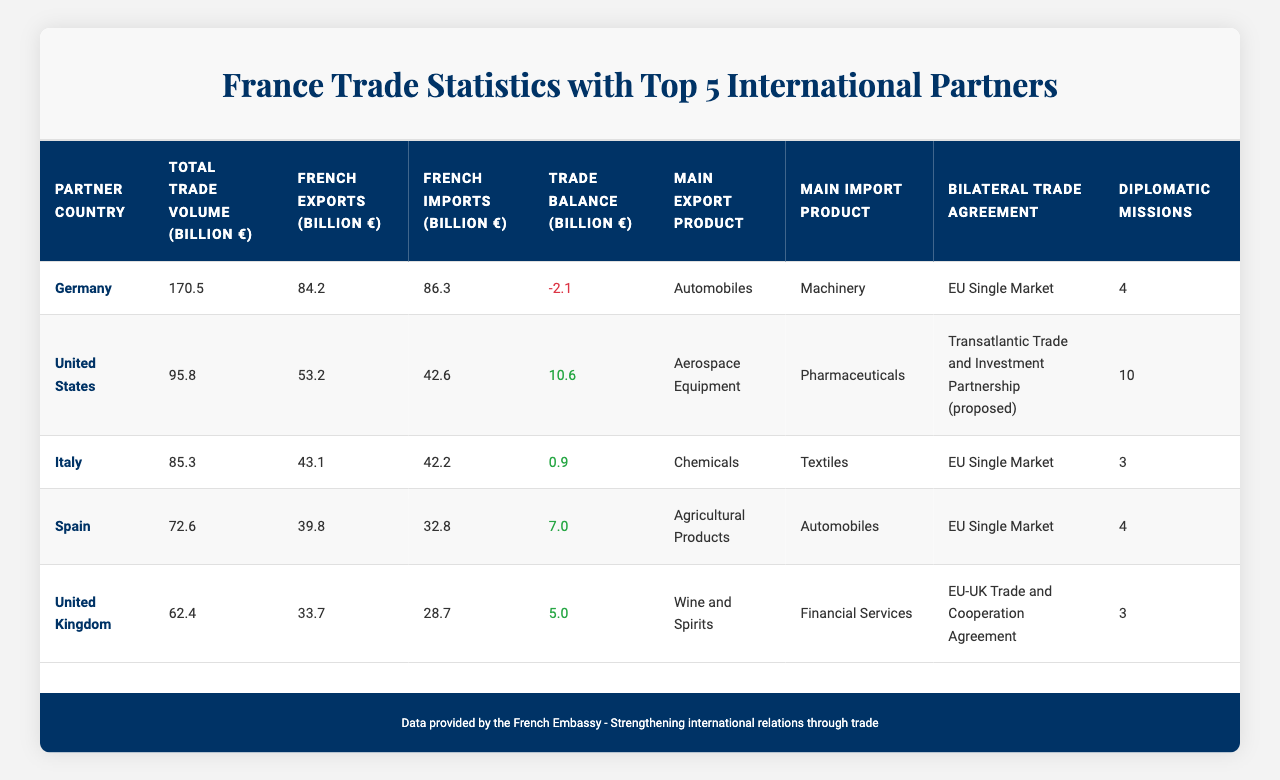What is the total trade volume with Germany? According to the table, the total trade volume with Germany is listed as 170.5 billion euros.
Answer: 170.5 billion € Which country has the highest French exports? The table shows that Germany has the highest French exports at 84.2 billion euros.
Answer: Germany Is the trade balance with Italy positive or negative? The trade balance with Italy is 0.9 billion euros, which is a positive value.
Answer: Positive What are the main export products to the United States? The main export product to the United States is Aerospace Equipment, as stated in the table.
Answer: Aerospace Equipment What is the difference in French imports between Germany and Spain? French imports from Germany are 86.3 billion euros, and from Spain, they are 32.8 billion euros. Therefore, the difference is 86.3 - 32.8 = 53.5 billion euros.
Answer: 53.5 billion € Which country has the lowest total trade volume with France? According to the table, the United Kingdom has the lowest total trade volume at 62.4 billion euros among the listed countries.
Answer: United Kingdom Is there a bilateral trade agreement with Italy? Yes, the table indicates that there is a bilateral trade agreement with Italy under the EU Single Market.
Answer: Yes Calculate the average trade balance for the top five partners. The trade balances are -2.1 (Germany), 10.6 (United States), 0.9 (Italy), 7.0 (Spain), and 5.0 (United Kingdom), which sums up to 21.4. Dividing by 5 gives an average of 21.4 / 5 = 4.28 billion euros.
Answer: 4.28 billion € What is the main import product from Spain? The main import product from Spain is Automobiles, as stated in the table.
Answer: Automobiles Which country has the most diplomatic missions from France? The table indicates that the United States has the most diplomatic missions from France, with a total of 10.
Answer: United States 